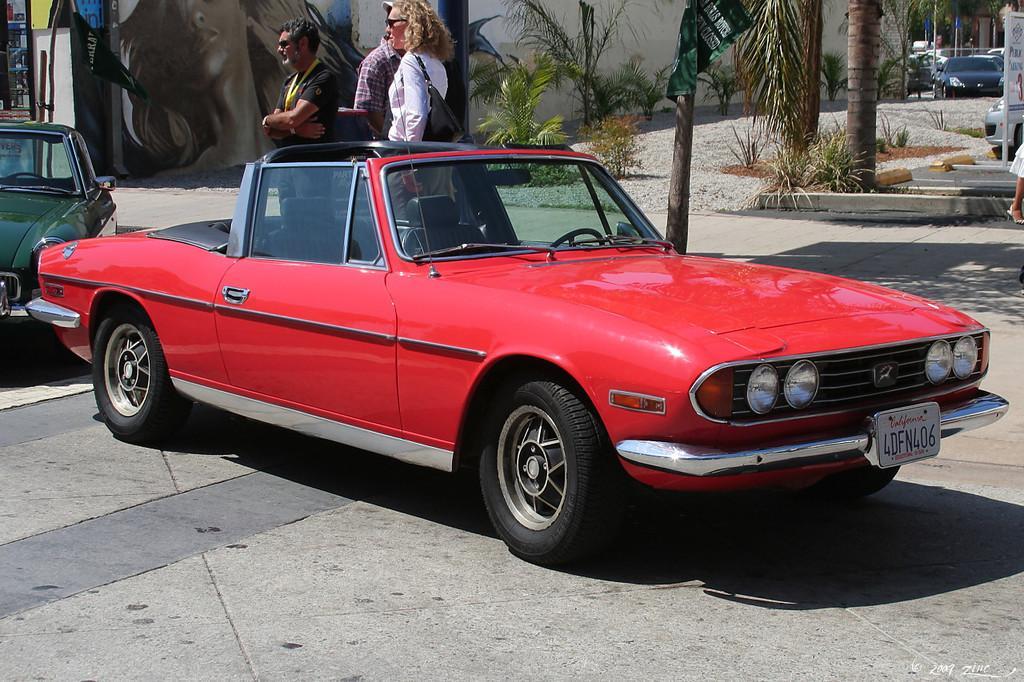Can you describe this image briefly? This image is taken doors. At the bottom of the image there is a floor. In the background there is a wall. There are a few plants. There is a gate. There are a few trees and a few cars are parked on the ground. On the left side of the image two cars are parked on the ground. In the middle of the image a few people are standing. On the right side of the image there are a few trees and there is a board with a text on it and a car is parked on the ground. 